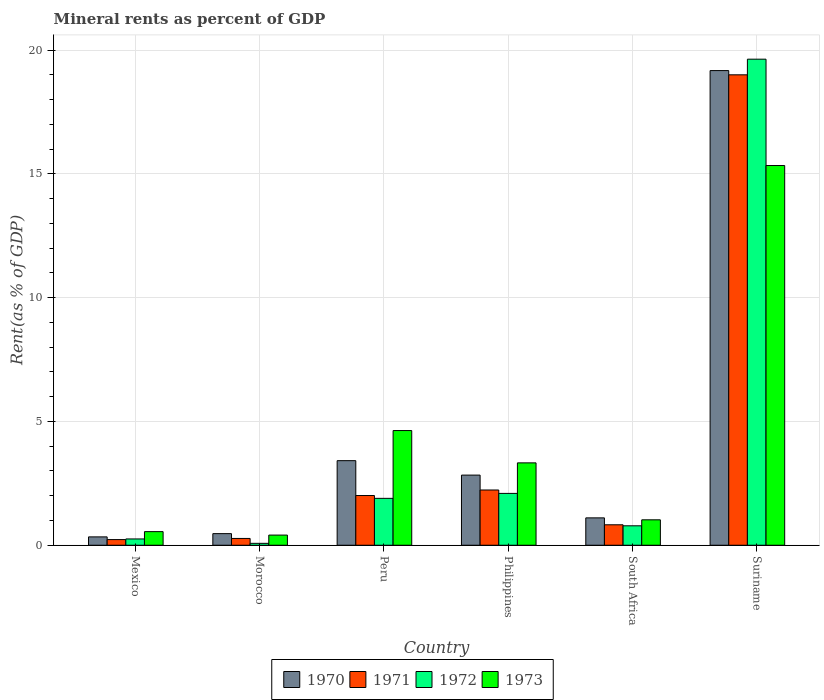How many different coloured bars are there?
Offer a very short reply. 4. How many groups of bars are there?
Offer a terse response. 6. Are the number of bars per tick equal to the number of legend labels?
Give a very brief answer. Yes. Are the number of bars on each tick of the X-axis equal?
Offer a terse response. Yes. What is the label of the 1st group of bars from the left?
Give a very brief answer. Mexico. What is the mineral rent in 1973 in Suriname?
Give a very brief answer. 15.34. Across all countries, what is the maximum mineral rent in 1972?
Your response must be concise. 19.63. Across all countries, what is the minimum mineral rent in 1972?
Your response must be concise. 0.08. In which country was the mineral rent in 1972 maximum?
Your response must be concise. Suriname. In which country was the mineral rent in 1972 minimum?
Give a very brief answer. Morocco. What is the total mineral rent in 1970 in the graph?
Your answer should be compact. 27.34. What is the difference between the mineral rent in 1972 in Mexico and that in Suriname?
Provide a short and direct response. -19.38. What is the difference between the mineral rent in 1971 in South Africa and the mineral rent in 1972 in Morocco?
Give a very brief answer. 0.75. What is the average mineral rent in 1973 per country?
Give a very brief answer. 4.21. What is the difference between the mineral rent of/in 1971 and mineral rent of/in 1973 in Peru?
Offer a very short reply. -2.62. What is the ratio of the mineral rent in 1971 in South Africa to that in Suriname?
Provide a short and direct response. 0.04. Is the mineral rent in 1973 in Peru less than that in Philippines?
Offer a very short reply. No. What is the difference between the highest and the second highest mineral rent in 1972?
Your answer should be compact. -0.2. What is the difference between the highest and the lowest mineral rent in 1973?
Provide a short and direct response. 14.93. Is it the case that in every country, the sum of the mineral rent in 1973 and mineral rent in 1971 is greater than the sum of mineral rent in 1970 and mineral rent in 1972?
Your response must be concise. No. Is it the case that in every country, the sum of the mineral rent in 1972 and mineral rent in 1971 is greater than the mineral rent in 1973?
Ensure brevity in your answer.  No. Are all the bars in the graph horizontal?
Offer a very short reply. No. Are the values on the major ticks of Y-axis written in scientific E-notation?
Offer a very short reply. No. Does the graph contain any zero values?
Give a very brief answer. No. Where does the legend appear in the graph?
Make the answer very short. Bottom center. How are the legend labels stacked?
Make the answer very short. Horizontal. What is the title of the graph?
Make the answer very short. Mineral rents as percent of GDP. Does "1990" appear as one of the legend labels in the graph?
Your answer should be very brief. No. What is the label or title of the Y-axis?
Make the answer very short. Rent(as % of GDP). What is the Rent(as % of GDP) of 1970 in Mexico?
Offer a very short reply. 0.34. What is the Rent(as % of GDP) of 1971 in Mexico?
Provide a short and direct response. 0.23. What is the Rent(as % of GDP) in 1972 in Mexico?
Offer a terse response. 0.25. What is the Rent(as % of GDP) of 1973 in Mexico?
Provide a short and direct response. 0.55. What is the Rent(as % of GDP) of 1970 in Morocco?
Ensure brevity in your answer.  0.47. What is the Rent(as % of GDP) of 1971 in Morocco?
Your answer should be very brief. 0.27. What is the Rent(as % of GDP) in 1972 in Morocco?
Make the answer very short. 0.08. What is the Rent(as % of GDP) of 1973 in Morocco?
Offer a terse response. 0.41. What is the Rent(as % of GDP) in 1970 in Peru?
Offer a terse response. 3.42. What is the Rent(as % of GDP) in 1971 in Peru?
Ensure brevity in your answer.  2.01. What is the Rent(as % of GDP) in 1972 in Peru?
Provide a succinct answer. 1.89. What is the Rent(as % of GDP) in 1973 in Peru?
Make the answer very short. 4.63. What is the Rent(as % of GDP) in 1970 in Philippines?
Make the answer very short. 2.83. What is the Rent(as % of GDP) in 1971 in Philippines?
Ensure brevity in your answer.  2.23. What is the Rent(as % of GDP) in 1972 in Philippines?
Ensure brevity in your answer.  2.09. What is the Rent(as % of GDP) in 1973 in Philippines?
Give a very brief answer. 3.33. What is the Rent(as % of GDP) of 1970 in South Africa?
Provide a short and direct response. 1.11. What is the Rent(as % of GDP) in 1971 in South Africa?
Keep it short and to the point. 0.83. What is the Rent(as % of GDP) of 1972 in South Africa?
Ensure brevity in your answer.  0.79. What is the Rent(as % of GDP) of 1973 in South Africa?
Your answer should be compact. 1.03. What is the Rent(as % of GDP) of 1970 in Suriname?
Your response must be concise. 19.17. What is the Rent(as % of GDP) in 1971 in Suriname?
Offer a very short reply. 19. What is the Rent(as % of GDP) of 1972 in Suriname?
Your answer should be very brief. 19.63. What is the Rent(as % of GDP) in 1973 in Suriname?
Give a very brief answer. 15.34. Across all countries, what is the maximum Rent(as % of GDP) in 1970?
Your answer should be very brief. 19.17. Across all countries, what is the maximum Rent(as % of GDP) of 1971?
Ensure brevity in your answer.  19. Across all countries, what is the maximum Rent(as % of GDP) of 1972?
Keep it short and to the point. 19.63. Across all countries, what is the maximum Rent(as % of GDP) in 1973?
Offer a very short reply. 15.34. Across all countries, what is the minimum Rent(as % of GDP) of 1970?
Ensure brevity in your answer.  0.34. Across all countries, what is the minimum Rent(as % of GDP) of 1971?
Provide a succinct answer. 0.23. Across all countries, what is the minimum Rent(as % of GDP) in 1972?
Your answer should be very brief. 0.08. Across all countries, what is the minimum Rent(as % of GDP) in 1973?
Keep it short and to the point. 0.41. What is the total Rent(as % of GDP) of 1970 in the graph?
Offer a terse response. 27.34. What is the total Rent(as % of GDP) of 1971 in the graph?
Your answer should be very brief. 24.57. What is the total Rent(as % of GDP) in 1972 in the graph?
Make the answer very short. 24.74. What is the total Rent(as % of GDP) of 1973 in the graph?
Give a very brief answer. 25.29. What is the difference between the Rent(as % of GDP) of 1970 in Mexico and that in Morocco?
Your answer should be compact. -0.13. What is the difference between the Rent(as % of GDP) in 1971 in Mexico and that in Morocco?
Provide a succinct answer. -0.05. What is the difference between the Rent(as % of GDP) of 1972 in Mexico and that in Morocco?
Keep it short and to the point. 0.18. What is the difference between the Rent(as % of GDP) in 1973 in Mexico and that in Morocco?
Give a very brief answer. 0.14. What is the difference between the Rent(as % of GDP) of 1970 in Mexico and that in Peru?
Make the answer very short. -3.08. What is the difference between the Rent(as % of GDP) in 1971 in Mexico and that in Peru?
Ensure brevity in your answer.  -1.78. What is the difference between the Rent(as % of GDP) in 1972 in Mexico and that in Peru?
Offer a terse response. -1.64. What is the difference between the Rent(as % of GDP) in 1973 in Mexico and that in Peru?
Your response must be concise. -4.08. What is the difference between the Rent(as % of GDP) in 1970 in Mexico and that in Philippines?
Your answer should be very brief. -2.5. What is the difference between the Rent(as % of GDP) in 1971 in Mexico and that in Philippines?
Offer a terse response. -2. What is the difference between the Rent(as % of GDP) of 1972 in Mexico and that in Philippines?
Make the answer very short. -1.84. What is the difference between the Rent(as % of GDP) of 1973 in Mexico and that in Philippines?
Offer a terse response. -2.78. What is the difference between the Rent(as % of GDP) in 1970 in Mexico and that in South Africa?
Keep it short and to the point. -0.77. What is the difference between the Rent(as % of GDP) in 1971 in Mexico and that in South Africa?
Keep it short and to the point. -0.6. What is the difference between the Rent(as % of GDP) in 1972 in Mexico and that in South Africa?
Make the answer very short. -0.53. What is the difference between the Rent(as % of GDP) of 1973 in Mexico and that in South Africa?
Provide a succinct answer. -0.48. What is the difference between the Rent(as % of GDP) of 1970 in Mexico and that in Suriname?
Offer a very short reply. -18.84. What is the difference between the Rent(as % of GDP) of 1971 in Mexico and that in Suriname?
Make the answer very short. -18.77. What is the difference between the Rent(as % of GDP) of 1972 in Mexico and that in Suriname?
Your answer should be very brief. -19.38. What is the difference between the Rent(as % of GDP) in 1973 in Mexico and that in Suriname?
Your answer should be very brief. -14.79. What is the difference between the Rent(as % of GDP) in 1970 in Morocco and that in Peru?
Your answer should be compact. -2.95. What is the difference between the Rent(as % of GDP) in 1971 in Morocco and that in Peru?
Keep it short and to the point. -1.73. What is the difference between the Rent(as % of GDP) of 1972 in Morocco and that in Peru?
Offer a very short reply. -1.82. What is the difference between the Rent(as % of GDP) of 1973 in Morocco and that in Peru?
Ensure brevity in your answer.  -4.22. What is the difference between the Rent(as % of GDP) of 1970 in Morocco and that in Philippines?
Ensure brevity in your answer.  -2.36. What is the difference between the Rent(as % of GDP) of 1971 in Morocco and that in Philippines?
Make the answer very short. -1.96. What is the difference between the Rent(as % of GDP) of 1972 in Morocco and that in Philippines?
Provide a succinct answer. -2.02. What is the difference between the Rent(as % of GDP) in 1973 in Morocco and that in Philippines?
Your answer should be compact. -2.92. What is the difference between the Rent(as % of GDP) in 1970 in Morocco and that in South Africa?
Give a very brief answer. -0.64. What is the difference between the Rent(as % of GDP) of 1971 in Morocco and that in South Africa?
Give a very brief answer. -0.55. What is the difference between the Rent(as % of GDP) of 1972 in Morocco and that in South Africa?
Provide a short and direct response. -0.71. What is the difference between the Rent(as % of GDP) in 1973 in Morocco and that in South Africa?
Offer a very short reply. -0.62. What is the difference between the Rent(as % of GDP) in 1970 in Morocco and that in Suriname?
Your answer should be very brief. -18.7. What is the difference between the Rent(as % of GDP) in 1971 in Morocco and that in Suriname?
Provide a succinct answer. -18.73. What is the difference between the Rent(as % of GDP) in 1972 in Morocco and that in Suriname?
Your answer should be very brief. -19.56. What is the difference between the Rent(as % of GDP) of 1973 in Morocco and that in Suriname?
Make the answer very short. -14.93. What is the difference between the Rent(as % of GDP) in 1970 in Peru and that in Philippines?
Your answer should be compact. 0.58. What is the difference between the Rent(as % of GDP) in 1971 in Peru and that in Philippines?
Your answer should be very brief. -0.22. What is the difference between the Rent(as % of GDP) in 1972 in Peru and that in Philippines?
Provide a short and direct response. -0.2. What is the difference between the Rent(as % of GDP) in 1973 in Peru and that in Philippines?
Your response must be concise. 1.31. What is the difference between the Rent(as % of GDP) in 1970 in Peru and that in South Africa?
Ensure brevity in your answer.  2.31. What is the difference between the Rent(as % of GDP) in 1971 in Peru and that in South Africa?
Give a very brief answer. 1.18. What is the difference between the Rent(as % of GDP) in 1972 in Peru and that in South Africa?
Give a very brief answer. 1.11. What is the difference between the Rent(as % of GDP) of 1973 in Peru and that in South Africa?
Offer a terse response. 3.61. What is the difference between the Rent(as % of GDP) of 1970 in Peru and that in Suriname?
Your answer should be compact. -15.76. What is the difference between the Rent(as % of GDP) of 1971 in Peru and that in Suriname?
Your answer should be very brief. -16.99. What is the difference between the Rent(as % of GDP) of 1972 in Peru and that in Suriname?
Provide a short and direct response. -17.74. What is the difference between the Rent(as % of GDP) in 1973 in Peru and that in Suriname?
Give a very brief answer. -10.71. What is the difference between the Rent(as % of GDP) of 1970 in Philippines and that in South Africa?
Provide a succinct answer. 1.73. What is the difference between the Rent(as % of GDP) in 1971 in Philippines and that in South Africa?
Provide a short and direct response. 1.41. What is the difference between the Rent(as % of GDP) in 1972 in Philippines and that in South Africa?
Give a very brief answer. 1.31. What is the difference between the Rent(as % of GDP) of 1973 in Philippines and that in South Africa?
Offer a terse response. 2.3. What is the difference between the Rent(as % of GDP) of 1970 in Philippines and that in Suriname?
Give a very brief answer. -16.34. What is the difference between the Rent(as % of GDP) of 1971 in Philippines and that in Suriname?
Provide a succinct answer. -16.77. What is the difference between the Rent(as % of GDP) in 1972 in Philippines and that in Suriname?
Provide a short and direct response. -17.54. What is the difference between the Rent(as % of GDP) of 1973 in Philippines and that in Suriname?
Offer a terse response. -12.01. What is the difference between the Rent(as % of GDP) in 1970 in South Africa and that in Suriname?
Make the answer very short. -18.07. What is the difference between the Rent(as % of GDP) in 1971 in South Africa and that in Suriname?
Ensure brevity in your answer.  -18.18. What is the difference between the Rent(as % of GDP) in 1972 in South Africa and that in Suriname?
Ensure brevity in your answer.  -18.85. What is the difference between the Rent(as % of GDP) of 1973 in South Africa and that in Suriname?
Ensure brevity in your answer.  -14.31. What is the difference between the Rent(as % of GDP) of 1970 in Mexico and the Rent(as % of GDP) of 1971 in Morocco?
Your answer should be very brief. 0.06. What is the difference between the Rent(as % of GDP) in 1970 in Mexico and the Rent(as % of GDP) in 1972 in Morocco?
Your answer should be compact. 0.26. What is the difference between the Rent(as % of GDP) in 1970 in Mexico and the Rent(as % of GDP) in 1973 in Morocco?
Your response must be concise. -0.07. What is the difference between the Rent(as % of GDP) in 1971 in Mexico and the Rent(as % of GDP) in 1972 in Morocco?
Ensure brevity in your answer.  0.15. What is the difference between the Rent(as % of GDP) of 1971 in Mexico and the Rent(as % of GDP) of 1973 in Morocco?
Keep it short and to the point. -0.18. What is the difference between the Rent(as % of GDP) of 1972 in Mexico and the Rent(as % of GDP) of 1973 in Morocco?
Provide a short and direct response. -0.16. What is the difference between the Rent(as % of GDP) in 1970 in Mexico and the Rent(as % of GDP) in 1971 in Peru?
Keep it short and to the point. -1.67. What is the difference between the Rent(as % of GDP) in 1970 in Mexico and the Rent(as % of GDP) in 1972 in Peru?
Offer a very short reply. -1.56. What is the difference between the Rent(as % of GDP) in 1970 in Mexico and the Rent(as % of GDP) in 1973 in Peru?
Offer a very short reply. -4.29. What is the difference between the Rent(as % of GDP) in 1971 in Mexico and the Rent(as % of GDP) in 1972 in Peru?
Provide a succinct answer. -1.67. What is the difference between the Rent(as % of GDP) in 1971 in Mexico and the Rent(as % of GDP) in 1973 in Peru?
Make the answer very short. -4.4. What is the difference between the Rent(as % of GDP) in 1972 in Mexico and the Rent(as % of GDP) in 1973 in Peru?
Your answer should be compact. -4.38. What is the difference between the Rent(as % of GDP) in 1970 in Mexico and the Rent(as % of GDP) in 1971 in Philippines?
Give a very brief answer. -1.89. What is the difference between the Rent(as % of GDP) of 1970 in Mexico and the Rent(as % of GDP) of 1972 in Philippines?
Make the answer very short. -1.76. What is the difference between the Rent(as % of GDP) in 1970 in Mexico and the Rent(as % of GDP) in 1973 in Philippines?
Offer a terse response. -2.99. What is the difference between the Rent(as % of GDP) in 1971 in Mexico and the Rent(as % of GDP) in 1972 in Philippines?
Offer a very short reply. -1.87. What is the difference between the Rent(as % of GDP) in 1971 in Mexico and the Rent(as % of GDP) in 1973 in Philippines?
Give a very brief answer. -3.1. What is the difference between the Rent(as % of GDP) in 1972 in Mexico and the Rent(as % of GDP) in 1973 in Philippines?
Your answer should be very brief. -3.07. What is the difference between the Rent(as % of GDP) of 1970 in Mexico and the Rent(as % of GDP) of 1971 in South Africa?
Make the answer very short. -0.49. What is the difference between the Rent(as % of GDP) of 1970 in Mexico and the Rent(as % of GDP) of 1972 in South Africa?
Give a very brief answer. -0.45. What is the difference between the Rent(as % of GDP) of 1970 in Mexico and the Rent(as % of GDP) of 1973 in South Africa?
Your answer should be very brief. -0.69. What is the difference between the Rent(as % of GDP) in 1971 in Mexico and the Rent(as % of GDP) in 1972 in South Africa?
Offer a very short reply. -0.56. What is the difference between the Rent(as % of GDP) of 1971 in Mexico and the Rent(as % of GDP) of 1973 in South Africa?
Give a very brief answer. -0.8. What is the difference between the Rent(as % of GDP) in 1972 in Mexico and the Rent(as % of GDP) in 1973 in South Africa?
Ensure brevity in your answer.  -0.77. What is the difference between the Rent(as % of GDP) in 1970 in Mexico and the Rent(as % of GDP) in 1971 in Suriname?
Keep it short and to the point. -18.66. What is the difference between the Rent(as % of GDP) in 1970 in Mexico and the Rent(as % of GDP) in 1972 in Suriname?
Provide a short and direct response. -19.3. What is the difference between the Rent(as % of GDP) of 1970 in Mexico and the Rent(as % of GDP) of 1973 in Suriname?
Offer a very short reply. -15. What is the difference between the Rent(as % of GDP) of 1971 in Mexico and the Rent(as % of GDP) of 1972 in Suriname?
Ensure brevity in your answer.  -19.41. What is the difference between the Rent(as % of GDP) in 1971 in Mexico and the Rent(as % of GDP) in 1973 in Suriname?
Give a very brief answer. -15.11. What is the difference between the Rent(as % of GDP) in 1972 in Mexico and the Rent(as % of GDP) in 1973 in Suriname?
Keep it short and to the point. -15.08. What is the difference between the Rent(as % of GDP) of 1970 in Morocco and the Rent(as % of GDP) of 1971 in Peru?
Offer a very short reply. -1.54. What is the difference between the Rent(as % of GDP) of 1970 in Morocco and the Rent(as % of GDP) of 1972 in Peru?
Offer a very short reply. -1.43. What is the difference between the Rent(as % of GDP) of 1970 in Morocco and the Rent(as % of GDP) of 1973 in Peru?
Ensure brevity in your answer.  -4.16. What is the difference between the Rent(as % of GDP) in 1971 in Morocco and the Rent(as % of GDP) in 1972 in Peru?
Your answer should be compact. -1.62. What is the difference between the Rent(as % of GDP) in 1971 in Morocco and the Rent(as % of GDP) in 1973 in Peru?
Make the answer very short. -4.36. What is the difference between the Rent(as % of GDP) of 1972 in Morocco and the Rent(as % of GDP) of 1973 in Peru?
Your answer should be very brief. -4.56. What is the difference between the Rent(as % of GDP) of 1970 in Morocco and the Rent(as % of GDP) of 1971 in Philippines?
Give a very brief answer. -1.76. What is the difference between the Rent(as % of GDP) in 1970 in Morocco and the Rent(as % of GDP) in 1972 in Philippines?
Your response must be concise. -1.63. What is the difference between the Rent(as % of GDP) of 1970 in Morocco and the Rent(as % of GDP) of 1973 in Philippines?
Your answer should be compact. -2.86. What is the difference between the Rent(as % of GDP) of 1971 in Morocco and the Rent(as % of GDP) of 1972 in Philippines?
Your answer should be very brief. -1.82. What is the difference between the Rent(as % of GDP) in 1971 in Morocco and the Rent(as % of GDP) in 1973 in Philippines?
Your answer should be very brief. -3.05. What is the difference between the Rent(as % of GDP) of 1972 in Morocco and the Rent(as % of GDP) of 1973 in Philippines?
Your answer should be compact. -3.25. What is the difference between the Rent(as % of GDP) of 1970 in Morocco and the Rent(as % of GDP) of 1971 in South Africa?
Provide a succinct answer. -0.36. What is the difference between the Rent(as % of GDP) in 1970 in Morocco and the Rent(as % of GDP) in 1972 in South Africa?
Keep it short and to the point. -0.32. What is the difference between the Rent(as % of GDP) in 1970 in Morocco and the Rent(as % of GDP) in 1973 in South Africa?
Give a very brief answer. -0.56. What is the difference between the Rent(as % of GDP) in 1971 in Morocco and the Rent(as % of GDP) in 1972 in South Africa?
Your response must be concise. -0.51. What is the difference between the Rent(as % of GDP) in 1971 in Morocco and the Rent(as % of GDP) in 1973 in South Africa?
Offer a very short reply. -0.75. What is the difference between the Rent(as % of GDP) in 1972 in Morocco and the Rent(as % of GDP) in 1973 in South Africa?
Ensure brevity in your answer.  -0.95. What is the difference between the Rent(as % of GDP) in 1970 in Morocco and the Rent(as % of GDP) in 1971 in Suriname?
Keep it short and to the point. -18.53. What is the difference between the Rent(as % of GDP) in 1970 in Morocco and the Rent(as % of GDP) in 1972 in Suriname?
Make the answer very short. -19.17. What is the difference between the Rent(as % of GDP) in 1970 in Morocco and the Rent(as % of GDP) in 1973 in Suriname?
Offer a very short reply. -14.87. What is the difference between the Rent(as % of GDP) of 1971 in Morocco and the Rent(as % of GDP) of 1972 in Suriname?
Make the answer very short. -19.36. What is the difference between the Rent(as % of GDP) in 1971 in Morocco and the Rent(as % of GDP) in 1973 in Suriname?
Ensure brevity in your answer.  -15.06. What is the difference between the Rent(as % of GDP) of 1972 in Morocco and the Rent(as % of GDP) of 1973 in Suriname?
Give a very brief answer. -15.26. What is the difference between the Rent(as % of GDP) in 1970 in Peru and the Rent(as % of GDP) in 1971 in Philippines?
Offer a very short reply. 1.18. What is the difference between the Rent(as % of GDP) of 1970 in Peru and the Rent(as % of GDP) of 1972 in Philippines?
Your response must be concise. 1.32. What is the difference between the Rent(as % of GDP) in 1970 in Peru and the Rent(as % of GDP) in 1973 in Philippines?
Offer a terse response. 0.09. What is the difference between the Rent(as % of GDP) in 1971 in Peru and the Rent(as % of GDP) in 1972 in Philippines?
Your answer should be very brief. -0.09. What is the difference between the Rent(as % of GDP) in 1971 in Peru and the Rent(as % of GDP) in 1973 in Philippines?
Your answer should be very brief. -1.32. What is the difference between the Rent(as % of GDP) of 1972 in Peru and the Rent(as % of GDP) of 1973 in Philippines?
Provide a short and direct response. -1.43. What is the difference between the Rent(as % of GDP) in 1970 in Peru and the Rent(as % of GDP) in 1971 in South Africa?
Provide a short and direct response. 2.59. What is the difference between the Rent(as % of GDP) of 1970 in Peru and the Rent(as % of GDP) of 1972 in South Africa?
Provide a short and direct response. 2.63. What is the difference between the Rent(as % of GDP) in 1970 in Peru and the Rent(as % of GDP) in 1973 in South Africa?
Your answer should be very brief. 2.39. What is the difference between the Rent(as % of GDP) of 1971 in Peru and the Rent(as % of GDP) of 1972 in South Africa?
Give a very brief answer. 1.22. What is the difference between the Rent(as % of GDP) of 1971 in Peru and the Rent(as % of GDP) of 1973 in South Africa?
Ensure brevity in your answer.  0.98. What is the difference between the Rent(as % of GDP) of 1972 in Peru and the Rent(as % of GDP) of 1973 in South Africa?
Your answer should be compact. 0.87. What is the difference between the Rent(as % of GDP) of 1970 in Peru and the Rent(as % of GDP) of 1971 in Suriname?
Keep it short and to the point. -15.59. What is the difference between the Rent(as % of GDP) of 1970 in Peru and the Rent(as % of GDP) of 1972 in Suriname?
Keep it short and to the point. -16.22. What is the difference between the Rent(as % of GDP) of 1970 in Peru and the Rent(as % of GDP) of 1973 in Suriname?
Make the answer very short. -11.92. What is the difference between the Rent(as % of GDP) in 1971 in Peru and the Rent(as % of GDP) in 1972 in Suriname?
Your answer should be very brief. -17.63. What is the difference between the Rent(as % of GDP) of 1971 in Peru and the Rent(as % of GDP) of 1973 in Suriname?
Offer a very short reply. -13.33. What is the difference between the Rent(as % of GDP) in 1972 in Peru and the Rent(as % of GDP) in 1973 in Suriname?
Offer a terse response. -13.44. What is the difference between the Rent(as % of GDP) of 1970 in Philippines and the Rent(as % of GDP) of 1971 in South Africa?
Ensure brevity in your answer.  2.01. What is the difference between the Rent(as % of GDP) in 1970 in Philippines and the Rent(as % of GDP) in 1972 in South Africa?
Your response must be concise. 2.05. What is the difference between the Rent(as % of GDP) in 1970 in Philippines and the Rent(as % of GDP) in 1973 in South Africa?
Give a very brief answer. 1.81. What is the difference between the Rent(as % of GDP) in 1971 in Philippines and the Rent(as % of GDP) in 1972 in South Africa?
Make the answer very short. 1.45. What is the difference between the Rent(as % of GDP) in 1971 in Philippines and the Rent(as % of GDP) in 1973 in South Africa?
Keep it short and to the point. 1.2. What is the difference between the Rent(as % of GDP) in 1972 in Philippines and the Rent(as % of GDP) in 1973 in South Africa?
Give a very brief answer. 1.07. What is the difference between the Rent(as % of GDP) of 1970 in Philippines and the Rent(as % of GDP) of 1971 in Suriname?
Keep it short and to the point. -16.17. What is the difference between the Rent(as % of GDP) in 1970 in Philippines and the Rent(as % of GDP) in 1972 in Suriname?
Give a very brief answer. -16.8. What is the difference between the Rent(as % of GDP) of 1970 in Philippines and the Rent(as % of GDP) of 1973 in Suriname?
Offer a terse response. -12.51. What is the difference between the Rent(as % of GDP) in 1971 in Philippines and the Rent(as % of GDP) in 1972 in Suriname?
Make the answer very short. -17.4. What is the difference between the Rent(as % of GDP) in 1971 in Philippines and the Rent(as % of GDP) in 1973 in Suriname?
Make the answer very short. -13.11. What is the difference between the Rent(as % of GDP) in 1972 in Philippines and the Rent(as % of GDP) in 1973 in Suriname?
Offer a terse response. -13.24. What is the difference between the Rent(as % of GDP) in 1970 in South Africa and the Rent(as % of GDP) in 1971 in Suriname?
Provide a succinct answer. -17.9. What is the difference between the Rent(as % of GDP) in 1970 in South Africa and the Rent(as % of GDP) in 1972 in Suriname?
Keep it short and to the point. -18.53. What is the difference between the Rent(as % of GDP) in 1970 in South Africa and the Rent(as % of GDP) in 1973 in Suriname?
Your response must be concise. -14.23. What is the difference between the Rent(as % of GDP) in 1971 in South Africa and the Rent(as % of GDP) in 1972 in Suriname?
Give a very brief answer. -18.81. What is the difference between the Rent(as % of GDP) of 1971 in South Africa and the Rent(as % of GDP) of 1973 in Suriname?
Give a very brief answer. -14.51. What is the difference between the Rent(as % of GDP) in 1972 in South Africa and the Rent(as % of GDP) in 1973 in Suriname?
Your answer should be very brief. -14.55. What is the average Rent(as % of GDP) in 1970 per country?
Your answer should be very brief. 4.56. What is the average Rent(as % of GDP) of 1971 per country?
Make the answer very short. 4.1. What is the average Rent(as % of GDP) in 1972 per country?
Offer a very short reply. 4.12. What is the average Rent(as % of GDP) of 1973 per country?
Your answer should be very brief. 4.21. What is the difference between the Rent(as % of GDP) of 1970 and Rent(as % of GDP) of 1971 in Mexico?
Offer a terse response. 0.11. What is the difference between the Rent(as % of GDP) in 1970 and Rent(as % of GDP) in 1972 in Mexico?
Make the answer very short. 0.08. What is the difference between the Rent(as % of GDP) of 1970 and Rent(as % of GDP) of 1973 in Mexico?
Give a very brief answer. -0.21. What is the difference between the Rent(as % of GDP) of 1971 and Rent(as % of GDP) of 1972 in Mexico?
Provide a succinct answer. -0.03. What is the difference between the Rent(as % of GDP) of 1971 and Rent(as % of GDP) of 1973 in Mexico?
Give a very brief answer. -0.32. What is the difference between the Rent(as % of GDP) in 1972 and Rent(as % of GDP) in 1973 in Mexico?
Your answer should be compact. -0.3. What is the difference between the Rent(as % of GDP) of 1970 and Rent(as % of GDP) of 1971 in Morocco?
Ensure brevity in your answer.  0.19. What is the difference between the Rent(as % of GDP) of 1970 and Rent(as % of GDP) of 1972 in Morocco?
Give a very brief answer. 0.39. What is the difference between the Rent(as % of GDP) in 1970 and Rent(as % of GDP) in 1973 in Morocco?
Your response must be concise. 0.06. What is the difference between the Rent(as % of GDP) in 1971 and Rent(as % of GDP) in 1972 in Morocco?
Make the answer very short. 0.2. What is the difference between the Rent(as % of GDP) of 1971 and Rent(as % of GDP) of 1973 in Morocco?
Provide a short and direct response. -0.14. What is the difference between the Rent(as % of GDP) in 1972 and Rent(as % of GDP) in 1973 in Morocco?
Provide a succinct answer. -0.33. What is the difference between the Rent(as % of GDP) of 1970 and Rent(as % of GDP) of 1971 in Peru?
Your response must be concise. 1.41. What is the difference between the Rent(as % of GDP) in 1970 and Rent(as % of GDP) in 1972 in Peru?
Give a very brief answer. 1.52. What is the difference between the Rent(as % of GDP) in 1970 and Rent(as % of GDP) in 1973 in Peru?
Provide a succinct answer. -1.22. What is the difference between the Rent(as % of GDP) of 1971 and Rent(as % of GDP) of 1972 in Peru?
Give a very brief answer. 0.11. What is the difference between the Rent(as % of GDP) in 1971 and Rent(as % of GDP) in 1973 in Peru?
Your response must be concise. -2.62. What is the difference between the Rent(as % of GDP) of 1972 and Rent(as % of GDP) of 1973 in Peru?
Offer a very short reply. -2.74. What is the difference between the Rent(as % of GDP) in 1970 and Rent(as % of GDP) in 1971 in Philippines?
Your answer should be compact. 0.6. What is the difference between the Rent(as % of GDP) in 1970 and Rent(as % of GDP) in 1972 in Philippines?
Provide a succinct answer. 0.74. What is the difference between the Rent(as % of GDP) of 1970 and Rent(as % of GDP) of 1973 in Philippines?
Offer a very short reply. -0.49. What is the difference between the Rent(as % of GDP) in 1971 and Rent(as % of GDP) in 1972 in Philippines?
Keep it short and to the point. 0.14. What is the difference between the Rent(as % of GDP) of 1971 and Rent(as % of GDP) of 1973 in Philippines?
Give a very brief answer. -1.1. What is the difference between the Rent(as % of GDP) of 1972 and Rent(as % of GDP) of 1973 in Philippines?
Offer a very short reply. -1.23. What is the difference between the Rent(as % of GDP) of 1970 and Rent(as % of GDP) of 1971 in South Africa?
Offer a very short reply. 0.28. What is the difference between the Rent(as % of GDP) in 1970 and Rent(as % of GDP) in 1972 in South Africa?
Offer a very short reply. 0.32. What is the difference between the Rent(as % of GDP) in 1970 and Rent(as % of GDP) in 1973 in South Africa?
Ensure brevity in your answer.  0.08. What is the difference between the Rent(as % of GDP) of 1971 and Rent(as % of GDP) of 1972 in South Africa?
Keep it short and to the point. 0.04. What is the difference between the Rent(as % of GDP) in 1971 and Rent(as % of GDP) in 1973 in South Africa?
Keep it short and to the point. -0.2. What is the difference between the Rent(as % of GDP) in 1972 and Rent(as % of GDP) in 1973 in South Africa?
Give a very brief answer. -0.24. What is the difference between the Rent(as % of GDP) in 1970 and Rent(as % of GDP) in 1971 in Suriname?
Provide a succinct answer. 0.17. What is the difference between the Rent(as % of GDP) in 1970 and Rent(as % of GDP) in 1972 in Suriname?
Your response must be concise. -0.46. What is the difference between the Rent(as % of GDP) of 1970 and Rent(as % of GDP) of 1973 in Suriname?
Your response must be concise. 3.84. What is the difference between the Rent(as % of GDP) of 1971 and Rent(as % of GDP) of 1972 in Suriname?
Offer a terse response. -0.63. What is the difference between the Rent(as % of GDP) in 1971 and Rent(as % of GDP) in 1973 in Suriname?
Offer a very short reply. 3.66. What is the difference between the Rent(as % of GDP) of 1972 and Rent(as % of GDP) of 1973 in Suriname?
Ensure brevity in your answer.  4.3. What is the ratio of the Rent(as % of GDP) of 1970 in Mexico to that in Morocco?
Ensure brevity in your answer.  0.72. What is the ratio of the Rent(as % of GDP) in 1971 in Mexico to that in Morocco?
Your answer should be very brief. 0.83. What is the ratio of the Rent(as % of GDP) in 1972 in Mexico to that in Morocco?
Offer a very short reply. 3.31. What is the ratio of the Rent(as % of GDP) in 1973 in Mexico to that in Morocco?
Offer a terse response. 1.34. What is the ratio of the Rent(as % of GDP) in 1970 in Mexico to that in Peru?
Provide a short and direct response. 0.1. What is the ratio of the Rent(as % of GDP) of 1971 in Mexico to that in Peru?
Offer a very short reply. 0.11. What is the ratio of the Rent(as % of GDP) of 1972 in Mexico to that in Peru?
Keep it short and to the point. 0.13. What is the ratio of the Rent(as % of GDP) of 1973 in Mexico to that in Peru?
Your answer should be very brief. 0.12. What is the ratio of the Rent(as % of GDP) in 1970 in Mexico to that in Philippines?
Make the answer very short. 0.12. What is the ratio of the Rent(as % of GDP) in 1971 in Mexico to that in Philippines?
Your answer should be compact. 0.1. What is the ratio of the Rent(as % of GDP) in 1972 in Mexico to that in Philippines?
Provide a succinct answer. 0.12. What is the ratio of the Rent(as % of GDP) of 1973 in Mexico to that in Philippines?
Provide a succinct answer. 0.17. What is the ratio of the Rent(as % of GDP) in 1970 in Mexico to that in South Africa?
Give a very brief answer. 0.31. What is the ratio of the Rent(as % of GDP) in 1971 in Mexico to that in South Africa?
Your answer should be very brief. 0.28. What is the ratio of the Rent(as % of GDP) of 1972 in Mexico to that in South Africa?
Your response must be concise. 0.32. What is the ratio of the Rent(as % of GDP) of 1973 in Mexico to that in South Africa?
Your response must be concise. 0.54. What is the ratio of the Rent(as % of GDP) in 1970 in Mexico to that in Suriname?
Provide a short and direct response. 0.02. What is the ratio of the Rent(as % of GDP) of 1971 in Mexico to that in Suriname?
Offer a terse response. 0.01. What is the ratio of the Rent(as % of GDP) in 1972 in Mexico to that in Suriname?
Make the answer very short. 0.01. What is the ratio of the Rent(as % of GDP) in 1973 in Mexico to that in Suriname?
Your response must be concise. 0.04. What is the ratio of the Rent(as % of GDP) in 1970 in Morocco to that in Peru?
Provide a short and direct response. 0.14. What is the ratio of the Rent(as % of GDP) of 1971 in Morocco to that in Peru?
Keep it short and to the point. 0.14. What is the ratio of the Rent(as % of GDP) of 1972 in Morocco to that in Peru?
Provide a succinct answer. 0.04. What is the ratio of the Rent(as % of GDP) of 1973 in Morocco to that in Peru?
Offer a very short reply. 0.09. What is the ratio of the Rent(as % of GDP) of 1970 in Morocco to that in Philippines?
Your answer should be compact. 0.17. What is the ratio of the Rent(as % of GDP) in 1971 in Morocco to that in Philippines?
Give a very brief answer. 0.12. What is the ratio of the Rent(as % of GDP) in 1972 in Morocco to that in Philippines?
Make the answer very short. 0.04. What is the ratio of the Rent(as % of GDP) of 1973 in Morocco to that in Philippines?
Ensure brevity in your answer.  0.12. What is the ratio of the Rent(as % of GDP) of 1970 in Morocco to that in South Africa?
Provide a short and direct response. 0.42. What is the ratio of the Rent(as % of GDP) of 1971 in Morocco to that in South Africa?
Provide a short and direct response. 0.33. What is the ratio of the Rent(as % of GDP) in 1972 in Morocco to that in South Africa?
Provide a short and direct response. 0.1. What is the ratio of the Rent(as % of GDP) of 1973 in Morocco to that in South Africa?
Ensure brevity in your answer.  0.4. What is the ratio of the Rent(as % of GDP) in 1970 in Morocco to that in Suriname?
Make the answer very short. 0.02. What is the ratio of the Rent(as % of GDP) of 1971 in Morocco to that in Suriname?
Provide a succinct answer. 0.01. What is the ratio of the Rent(as % of GDP) in 1972 in Morocco to that in Suriname?
Offer a terse response. 0. What is the ratio of the Rent(as % of GDP) of 1973 in Morocco to that in Suriname?
Give a very brief answer. 0.03. What is the ratio of the Rent(as % of GDP) in 1970 in Peru to that in Philippines?
Keep it short and to the point. 1.21. What is the ratio of the Rent(as % of GDP) of 1971 in Peru to that in Philippines?
Provide a succinct answer. 0.9. What is the ratio of the Rent(as % of GDP) in 1972 in Peru to that in Philippines?
Provide a short and direct response. 0.9. What is the ratio of the Rent(as % of GDP) in 1973 in Peru to that in Philippines?
Your answer should be compact. 1.39. What is the ratio of the Rent(as % of GDP) in 1970 in Peru to that in South Africa?
Provide a succinct answer. 3.09. What is the ratio of the Rent(as % of GDP) in 1971 in Peru to that in South Africa?
Your response must be concise. 2.43. What is the ratio of the Rent(as % of GDP) of 1972 in Peru to that in South Africa?
Ensure brevity in your answer.  2.41. What is the ratio of the Rent(as % of GDP) of 1973 in Peru to that in South Africa?
Keep it short and to the point. 4.51. What is the ratio of the Rent(as % of GDP) of 1970 in Peru to that in Suriname?
Give a very brief answer. 0.18. What is the ratio of the Rent(as % of GDP) of 1971 in Peru to that in Suriname?
Ensure brevity in your answer.  0.11. What is the ratio of the Rent(as % of GDP) of 1972 in Peru to that in Suriname?
Give a very brief answer. 0.1. What is the ratio of the Rent(as % of GDP) in 1973 in Peru to that in Suriname?
Offer a terse response. 0.3. What is the ratio of the Rent(as % of GDP) of 1970 in Philippines to that in South Africa?
Offer a very short reply. 2.56. What is the ratio of the Rent(as % of GDP) in 1971 in Philippines to that in South Africa?
Your answer should be compact. 2.7. What is the ratio of the Rent(as % of GDP) in 1972 in Philippines to that in South Africa?
Offer a very short reply. 2.67. What is the ratio of the Rent(as % of GDP) of 1973 in Philippines to that in South Africa?
Offer a very short reply. 3.24. What is the ratio of the Rent(as % of GDP) of 1970 in Philippines to that in Suriname?
Your response must be concise. 0.15. What is the ratio of the Rent(as % of GDP) of 1971 in Philippines to that in Suriname?
Provide a short and direct response. 0.12. What is the ratio of the Rent(as % of GDP) in 1972 in Philippines to that in Suriname?
Your answer should be compact. 0.11. What is the ratio of the Rent(as % of GDP) in 1973 in Philippines to that in Suriname?
Offer a very short reply. 0.22. What is the ratio of the Rent(as % of GDP) of 1970 in South Africa to that in Suriname?
Keep it short and to the point. 0.06. What is the ratio of the Rent(as % of GDP) in 1971 in South Africa to that in Suriname?
Make the answer very short. 0.04. What is the ratio of the Rent(as % of GDP) in 1972 in South Africa to that in Suriname?
Ensure brevity in your answer.  0.04. What is the ratio of the Rent(as % of GDP) of 1973 in South Africa to that in Suriname?
Offer a very short reply. 0.07. What is the difference between the highest and the second highest Rent(as % of GDP) in 1970?
Offer a terse response. 15.76. What is the difference between the highest and the second highest Rent(as % of GDP) in 1971?
Offer a terse response. 16.77. What is the difference between the highest and the second highest Rent(as % of GDP) in 1972?
Make the answer very short. 17.54. What is the difference between the highest and the second highest Rent(as % of GDP) in 1973?
Make the answer very short. 10.71. What is the difference between the highest and the lowest Rent(as % of GDP) of 1970?
Keep it short and to the point. 18.84. What is the difference between the highest and the lowest Rent(as % of GDP) in 1971?
Offer a very short reply. 18.77. What is the difference between the highest and the lowest Rent(as % of GDP) in 1972?
Provide a succinct answer. 19.56. What is the difference between the highest and the lowest Rent(as % of GDP) of 1973?
Your answer should be very brief. 14.93. 